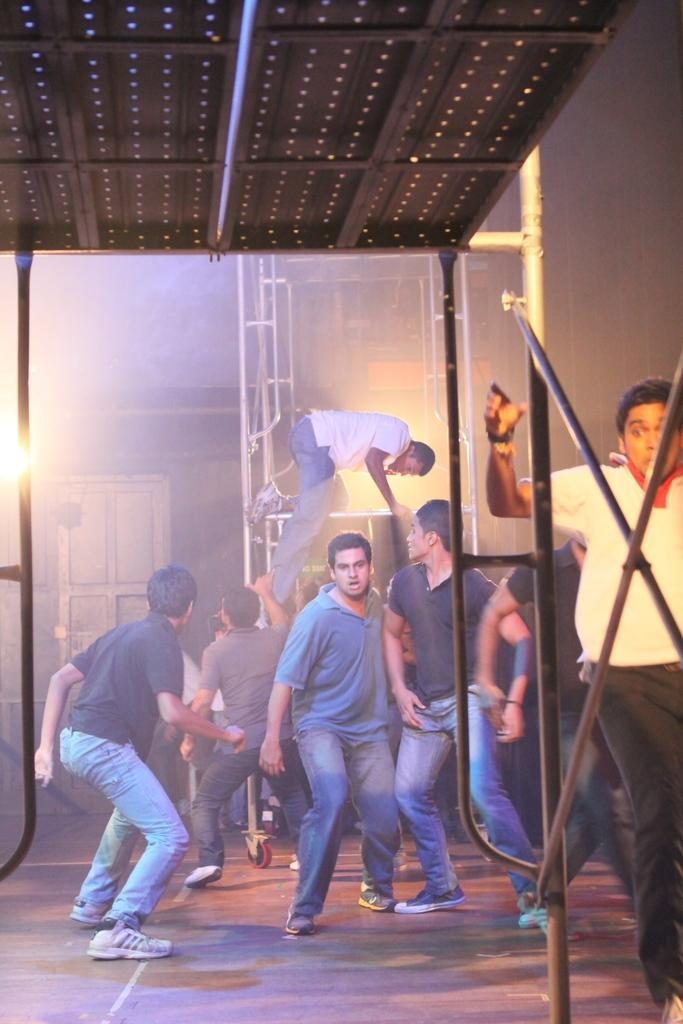What are the people in the image doing? The people in the image are in motion. What metal object with rods can be seen in the image? There is a metal object with rods in the image. What can be seen in the background of the image? In the background of the image, there are rods, a wall, lights, and a door. What type of quince is being served at the police stage in the image? There is no mention of a police stage or quince in the image; it features people in motion and a metal object with rods, along with various background elements. 